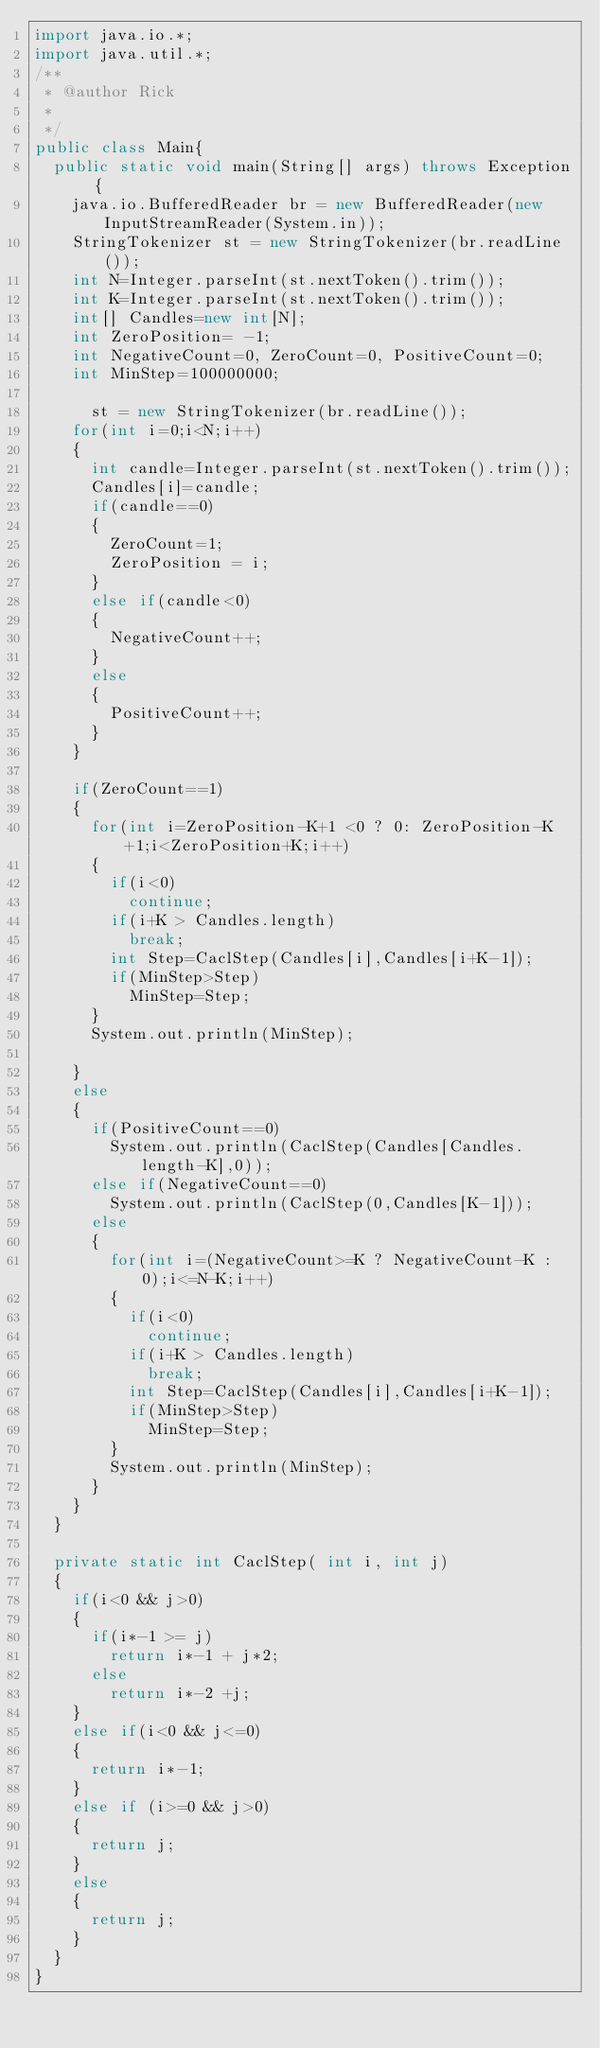<code> <loc_0><loc_0><loc_500><loc_500><_Java_>import java.io.*;
import java.util.*;
/**
 * @author Rick
 *
 */
public class Main{
	public static void main(String[] args) throws Exception {
		java.io.BufferedReader br = new BufferedReader(new InputStreamReader(System.in));
		StringTokenizer st = new StringTokenizer(br.readLine());
		int N=Integer.parseInt(st.nextToken().trim());
		int K=Integer.parseInt(st.nextToken().trim());
		int[] Candles=new int[N];
		int ZeroPosition= -1;
		int NegativeCount=0, ZeroCount=0, PositiveCount=0;
		int MinStep=100000000;
		
	    st = new StringTokenizer(br.readLine());
		for(int i=0;i<N;i++)
		{
			int candle=Integer.parseInt(st.nextToken().trim());
			Candles[i]=candle;
			if(candle==0)
			{
				ZeroCount=1;
				ZeroPosition = i;	
			}
			else if(candle<0)
			{
				NegativeCount++;
			}
			else
			{
				PositiveCount++;
			}
		}
		
		if(ZeroCount==1)
		{
			for(int i=ZeroPosition-K+1 <0 ? 0: ZeroPosition-K+1;i<ZeroPosition+K;i++)
			{
				if(i<0)
					continue;
				if(i+K > Candles.length)
					break;
				int Step=CaclStep(Candles[i],Candles[i+K-1]);
				if(MinStep>Step)
					MinStep=Step;				
			}
			System.out.println(MinStep);
			
		}
		else
		{
			if(PositiveCount==0)
				System.out.println(CaclStep(Candles[Candles.length-K],0));
			else if(NegativeCount==0)
				System.out.println(CaclStep(0,Candles[K-1]));
			else
			{	
				for(int i=(NegativeCount>=K ? NegativeCount-K : 0);i<=N-K;i++)
				{
					if(i<0)
						continue;
					if(i+K > Candles.length)
						break;
					int Step=CaclStep(Candles[i],Candles[i+K-1]);
					if(MinStep>Step)
						MinStep=Step;				
				}
				System.out.println(MinStep);
			}
		}
	}
	
	private static int CaclStep( int i, int j)
	{
		if(i<0 && j>0)
		{
			if(i*-1 >= j)
				return i*-1 + j*2;
			else
				return i*-2 +j;
		}
		else if(i<0 && j<=0)
		{
			return i*-1;
		}
		else if (i>=0 && j>0)
		{ 
			return j;
		}
		else
		{ 
			return j;
		}
	}
}</code> 